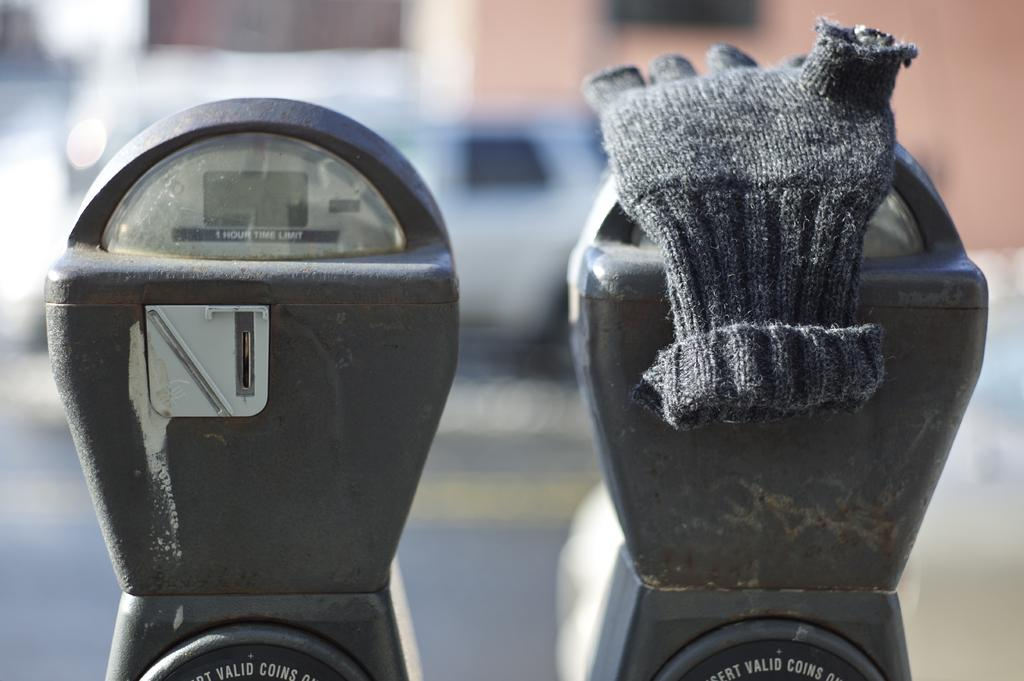What objects are present in the image related to parking? There are parking meters in the image. Is there anything unusual on the parking meters? Yes, a pair of gloves is on one of the parking meters. What can be observed about the overall image quality? The background of the image is blurry. Can you describe any vehicles visible in the image? There is a vehicle visible in the background. What type of hose is being used by the person in the image? There is no hose present in the image. How does the person in the image feel about the gloves on the parking meter? The image does not provide any information about the person's feelings or emotions. 